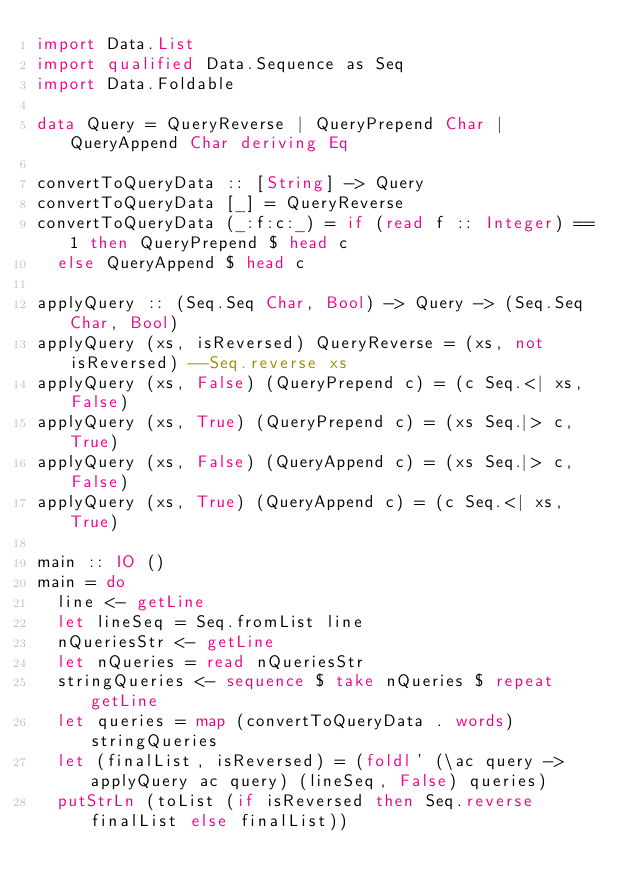<code> <loc_0><loc_0><loc_500><loc_500><_Haskell_>import Data.List
import qualified Data.Sequence as Seq
import Data.Foldable

data Query = QueryReverse | QueryPrepend Char | QueryAppend Char deriving Eq

convertToQueryData :: [String] -> Query
convertToQueryData [_] = QueryReverse
convertToQueryData (_:f:c:_) = if (read f :: Integer) == 1 then QueryPrepend $ head c
  else QueryAppend $ head c

applyQuery :: (Seq.Seq Char, Bool) -> Query -> (Seq.Seq Char, Bool)
applyQuery (xs, isReversed) QueryReverse = (xs, not isReversed) --Seq.reverse xs
applyQuery (xs, False) (QueryPrepend c) = (c Seq.<| xs, False)
applyQuery (xs, True) (QueryPrepend c) = (xs Seq.|> c, True)
applyQuery (xs, False) (QueryAppend c) = (xs Seq.|> c, False)
applyQuery (xs, True) (QueryAppend c) = (c Seq.<| xs, True)

main :: IO ()
main = do
  line <- getLine
  let lineSeq = Seq.fromList line
  nQueriesStr <- getLine
  let nQueries = read nQueriesStr
  stringQueries <- sequence $ take nQueries $ repeat getLine
  let queries = map (convertToQueryData . words) stringQueries
  let (finalList, isReversed) = (foldl' (\ac query -> applyQuery ac query) (lineSeq, False) queries)
  putStrLn (toList (if isReversed then Seq.reverse finalList else finalList))
</code> 